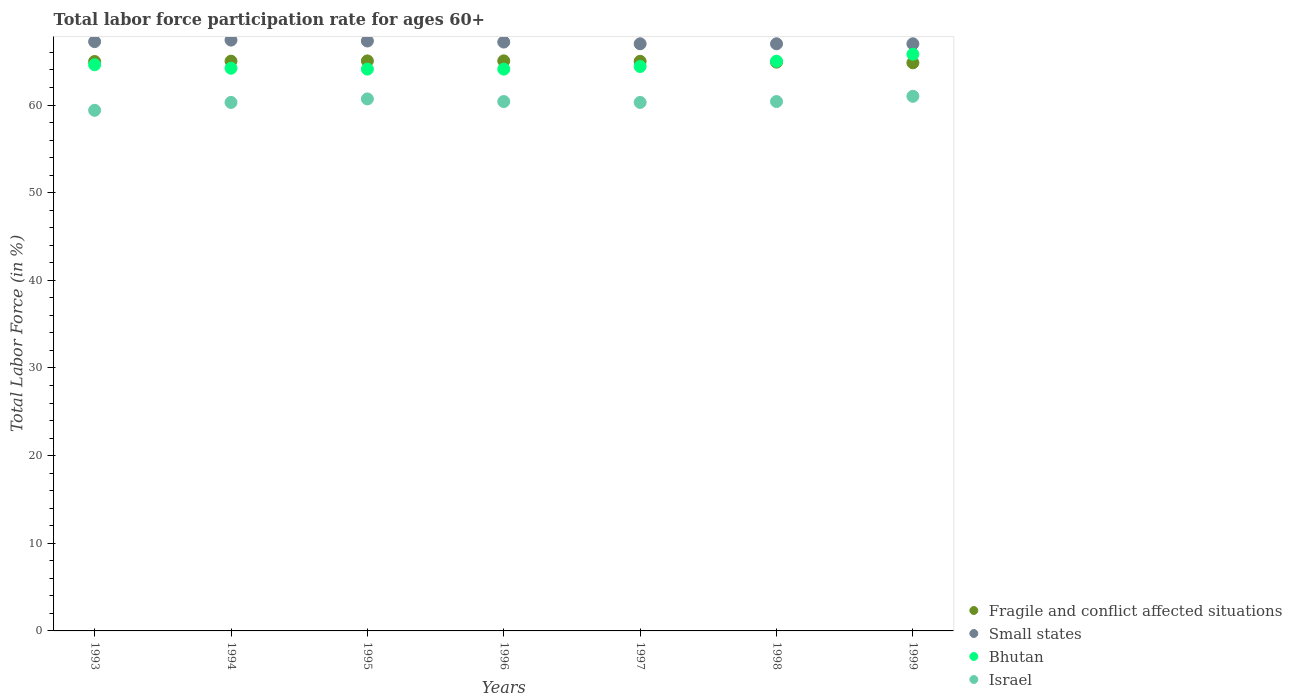Is the number of dotlines equal to the number of legend labels?
Offer a terse response. Yes. What is the labor force participation rate in Israel in 1993?
Provide a succinct answer. 59.4. Across all years, what is the maximum labor force participation rate in Fragile and conflict affected situations?
Your answer should be compact. 65.04. Across all years, what is the minimum labor force participation rate in Fragile and conflict affected situations?
Give a very brief answer. 64.82. In which year was the labor force participation rate in Small states minimum?
Give a very brief answer. 1999. What is the total labor force participation rate in Bhutan in the graph?
Provide a short and direct response. 452.2. What is the difference between the labor force participation rate in Bhutan in 1996 and that in 1998?
Make the answer very short. -0.9. What is the difference between the labor force participation rate in Small states in 1993 and the labor force participation rate in Israel in 1999?
Offer a very short reply. 6.24. What is the average labor force participation rate in Small states per year?
Keep it short and to the point. 67.16. In the year 1997, what is the difference between the labor force participation rate in Small states and labor force participation rate in Israel?
Keep it short and to the point. 6.69. In how many years, is the labor force participation rate in Bhutan greater than 10 %?
Your answer should be compact. 7. What is the ratio of the labor force participation rate in Small states in 1994 to that in 1995?
Your answer should be compact. 1. Is the difference between the labor force participation rate in Small states in 1993 and 1995 greater than the difference between the labor force participation rate in Israel in 1993 and 1995?
Keep it short and to the point. Yes. What is the difference between the highest and the second highest labor force participation rate in Bhutan?
Keep it short and to the point. 0.8. What is the difference between the highest and the lowest labor force participation rate in Israel?
Give a very brief answer. 1.6. Is the sum of the labor force participation rate in Israel in 1994 and 1997 greater than the maximum labor force participation rate in Fragile and conflict affected situations across all years?
Your answer should be very brief. Yes. Is it the case that in every year, the sum of the labor force participation rate in Fragile and conflict affected situations and labor force participation rate in Israel  is greater than the labor force participation rate in Bhutan?
Ensure brevity in your answer.  Yes. Does the labor force participation rate in Israel monotonically increase over the years?
Keep it short and to the point. No. Is the labor force participation rate in Bhutan strictly greater than the labor force participation rate in Small states over the years?
Provide a succinct answer. No. How many dotlines are there?
Your answer should be very brief. 4. How many years are there in the graph?
Ensure brevity in your answer.  7. Are the values on the major ticks of Y-axis written in scientific E-notation?
Make the answer very short. No. Does the graph contain grids?
Make the answer very short. No. How are the legend labels stacked?
Your answer should be very brief. Vertical. What is the title of the graph?
Provide a short and direct response. Total labor force participation rate for ages 60+. Does "Switzerland" appear as one of the legend labels in the graph?
Keep it short and to the point. No. What is the label or title of the X-axis?
Your answer should be very brief. Years. What is the Total Labor Force (in %) of Fragile and conflict affected situations in 1993?
Offer a terse response. 64.97. What is the Total Labor Force (in %) of Small states in 1993?
Provide a short and direct response. 67.24. What is the Total Labor Force (in %) of Bhutan in 1993?
Give a very brief answer. 64.6. What is the Total Labor Force (in %) of Israel in 1993?
Give a very brief answer. 59.4. What is the Total Labor Force (in %) of Fragile and conflict affected situations in 1994?
Your response must be concise. 65.01. What is the Total Labor Force (in %) of Small states in 1994?
Your answer should be very brief. 67.41. What is the Total Labor Force (in %) of Bhutan in 1994?
Offer a very short reply. 64.2. What is the Total Labor Force (in %) of Israel in 1994?
Keep it short and to the point. 60.3. What is the Total Labor Force (in %) of Fragile and conflict affected situations in 1995?
Provide a succinct answer. 65.04. What is the Total Labor Force (in %) of Small states in 1995?
Keep it short and to the point. 67.31. What is the Total Labor Force (in %) of Bhutan in 1995?
Give a very brief answer. 64.1. What is the Total Labor Force (in %) of Israel in 1995?
Provide a short and direct response. 60.7. What is the Total Labor Force (in %) in Fragile and conflict affected situations in 1996?
Give a very brief answer. 65.04. What is the Total Labor Force (in %) of Small states in 1996?
Your response must be concise. 67.19. What is the Total Labor Force (in %) in Bhutan in 1996?
Your response must be concise. 64.1. What is the Total Labor Force (in %) in Israel in 1996?
Keep it short and to the point. 60.4. What is the Total Labor Force (in %) in Fragile and conflict affected situations in 1997?
Your response must be concise. 64.99. What is the Total Labor Force (in %) of Small states in 1997?
Keep it short and to the point. 66.99. What is the Total Labor Force (in %) of Bhutan in 1997?
Ensure brevity in your answer.  64.4. What is the Total Labor Force (in %) in Israel in 1997?
Provide a short and direct response. 60.3. What is the Total Labor Force (in %) of Fragile and conflict affected situations in 1998?
Provide a succinct answer. 64.9. What is the Total Labor Force (in %) of Small states in 1998?
Offer a terse response. 66.99. What is the Total Labor Force (in %) of Israel in 1998?
Provide a succinct answer. 60.4. What is the Total Labor Force (in %) of Fragile and conflict affected situations in 1999?
Offer a terse response. 64.82. What is the Total Labor Force (in %) of Small states in 1999?
Offer a very short reply. 66.99. What is the Total Labor Force (in %) of Bhutan in 1999?
Your answer should be compact. 65.8. Across all years, what is the maximum Total Labor Force (in %) of Fragile and conflict affected situations?
Your answer should be very brief. 65.04. Across all years, what is the maximum Total Labor Force (in %) in Small states?
Your answer should be very brief. 67.41. Across all years, what is the maximum Total Labor Force (in %) of Bhutan?
Your answer should be compact. 65.8. Across all years, what is the maximum Total Labor Force (in %) in Israel?
Offer a very short reply. 61. Across all years, what is the minimum Total Labor Force (in %) in Fragile and conflict affected situations?
Provide a short and direct response. 64.82. Across all years, what is the minimum Total Labor Force (in %) in Small states?
Give a very brief answer. 66.99. Across all years, what is the minimum Total Labor Force (in %) of Bhutan?
Keep it short and to the point. 64.1. Across all years, what is the minimum Total Labor Force (in %) of Israel?
Offer a terse response. 59.4. What is the total Total Labor Force (in %) of Fragile and conflict affected situations in the graph?
Provide a short and direct response. 454.77. What is the total Total Labor Force (in %) in Small states in the graph?
Your answer should be compact. 470.11. What is the total Total Labor Force (in %) of Bhutan in the graph?
Your response must be concise. 452.2. What is the total Total Labor Force (in %) of Israel in the graph?
Offer a terse response. 422.5. What is the difference between the Total Labor Force (in %) of Fragile and conflict affected situations in 1993 and that in 1994?
Your answer should be very brief. -0.04. What is the difference between the Total Labor Force (in %) in Small states in 1993 and that in 1994?
Offer a very short reply. -0.18. What is the difference between the Total Labor Force (in %) in Fragile and conflict affected situations in 1993 and that in 1995?
Offer a terse response. -0.07. What is the difference between the Total Labor Force (in %) in Small states in 1993 and that in 1995?
Give a very brief answer. -0.07. What is the difference between the Total Labor Force (in %) of Fragile and conflict affected situations in 1993 and that in 1996?
Make the answer very short. -0.07. What is the difference between the Total Labor Force (in %) of Small states in 1993 and that in 1996?
Offer a terse response. 0.05. What is the difference between the Total Labor Force (in %) of Israel in 1993 and that in 1996?
Your response must be concise. -1. What is the difference between the Total Labor Force (in %) of Fragile and conflict affected situations in 1993 and that in 1997?
Your answer should be very brief. -0.02. What is the difference between the Total Labor Force (in %) in Small states in 1993 and that in 1997?
Your answer should be very brief. 0.25. What is the difference between the Total Labor Force (in %) of Fragile and conflict affected situations in 1993 and that in 1998?
Offer a very short reply. 0.07. What is the difference between the Total Labor Force (in %) of Small states in 1993 and that in 1998?
Make the answer very short. 0.25. What is the difference between the Total Labor Force (in %) of Bhutan in 1993 and that in 1998?
Keep it short and to the point. -0.4. What is the difference between the Total Labor Force (in %) in Israel in 1993 and that in 1998?
Provide a succinct answer. -1. What is the difference between the Total Labor Force (in %) of Fragile and conflict affected situations in 1993 and that in 1999?
Offer a terse response. 0.15. What is the difference between the Total Labor Force (in %) in Small states in 1993 and that in 1999?
Keep it short and to the point. 0.25. What is the difference between the Total Labor Force (in %) of Fragile and conflict affected situations in 1994 and that in 1995?
Provide a short and direct response. -0.03. What is the difference between the Total Labor Force (in %) in Small states in 1994 and that in 1995?
Offer a terse response. 0.1. What is the difference between the Total Labor Force (in %) of Israel in 1994 and that in 1995?
Make the answer very short. -0.4. What is the difference between the Total Labor Force (in %) in Fragile and conflict affected situations in 1994 and that in 1996?
Offer a terse response. -0.04. What is the difference between the Total Labor Force (in %) in Small states in 1994 and that in 1996?
Your answer should be very brief. 0.23. What is the difference between the Total Labor Force (in %) of Fragile and conflict affected situations in 1994 and that in 1997?
Keep it short and to the point. 0.02. What is the difference between the Total Labor Force (in %) of Small states in 1994 and that in 1997?
Provide a succinct answer. 0.42. What is the difference between the Total Labor Force (in %) in Israel in 1994 and that in 1997?
Your response must be concise. 0. What is the difference between the Total Labor Force (in %) of Fragile and conflict affected situations in 1994 and that in 1998?
Ensure brevity in your answer.  0.11. What is the difference between the Total Labor Force (in %) in Small states in 1994 and that in 1998?
Provide a succinct answer. 0.42. What is the difference between the Total Labor Force (in %) of Israel in 1994 and that in 1998?
Ensure brevity in your answer.  -0.1. What is the difference between the Total Labor Force (in %) of Fragile and conflict affected situations in 1994 and that in 1999?
Provide a short and direct response. 0.19. What is the difference between the Total Labor Force (in %) in Small states in 1994 and that in 1999?
Provide a succinct answer. 0.42. What is the difference between the Total Labor Force (in %) of Bhutan in 1994 and that in 1999?
Your answer should be very brief. -1.6. What is the difference between the Total Labor Force (in %) in Fragile and conflict affected situations in 1995 and that in 1996?
Offer a very short reply. -0. What is the difference between the Total Labor Force (in %) in Small states in 1995 and that in 1996?
Your answer should be very brief. 0.12. What is the difference between the Total Labor Force (in %) of Fragile and conflict affected situations in 1995 and that in 1997?
Your response must be concise. 0.05. What is the difference between the Total Labor Force (in %) of Small states in 1995 and that in 1997?
Your answer should be very brief. 0.32. What is the difference between the Total Labor Force (in %) of Fragile and conflict affected situations in 1995 and that in 1998?
Ensure brevity in your answer.  0.14. What is the difference between the Total Labor Force (in %) in Small states in 1995 and that in 1998?
Ensure brevity in your answer.  0.32. What is the difference between the Total Labor Force (in %) of Bhutan in 1995 and that in 1998?
Offer a very short reply. -0.9. What is the difference between the Total Labor Force (in %) of Israel in 1995 and that in 1998?
Your answer should be very brief. 0.3. What is the difference between the Total Labor Force (in %) of Fragile and conflict affected situations in 1995 and that in 1999?
Your response must be concise. 0.22. What is the difference between the Total Labor Force (in %) in Small states in 1995 and that in 1999?
Give a very brief answer. 0.32. What is the difference between the Total Labor Force (in %) in Israel in 1995 and that in 1999?
Provide a short and direct response. -0.3. What is the difference between the Total Labor Force (in %) in Fragile and conflict affected situations in 1996 and that in 1997?
Provide a succinct answer. 0.05. What is the difference between the Total Labor Force (in %) of Small states in 1996 and that in 1997?
Ensure brevity in your answer.  0.2. What is the difference between the Total Labor Force (in %) in Bhutan in 1996 and that in 1997?
Provide a succinct answer. -0.3. What is the difference between the Total Labor Force (in %) in Fragile and conflict affected situations in 1996 and that in 1998?
Provide a short and direct response. 0.14. What is the difference between the Total Labor Force (in %) in Small states in 1996 and that in 1998?
Provide a succinct answer. 0.2. What is the difference between the Total Labor Force (in %) in Bhutan in 1996 and that in 1998?
Give a very brief answer. -0.9. What is the difference between the Total Labor Force (in %) in Fragile and conflict affected situations in 1996 and that in 1999?
Make the answer very short. 0.22. What is the difference between the Total Labor Force (in %) in Small states in 1996 and that in 1999?
Make the answer very short. 0.2. What is the difference between the Total Labor Force (in %) of Bhutan in 1996 and that in 1999?
Make the answer very short. -1.7. What is the difference between the Total Labor Force (in %) in Israel in 1996 and that in 1999?
Give a very brief answer. -0.6. What is the difference between the Total Labor Force (in %) of Fragile and conflict affected situations in 1997 and that in 1998?
Give a very brief answer. 0.09. What is the difference between the Total Labor Force (in %) of Small states in 1997 and that in 1998?
Offer a terse response. 0. What is the difference between the Total Labor Force (in %) in Bhutan in 1997 and that in 1998?
Provide a short and direct response. -0.6. What is the difference between the Total Labor Force (in %) of Israel in 1997 and that in 1998?
Keep it short and to the point. -0.1. What is the difference between the Total Labor Force (in %) in Fragile and conflict affected situations in 1997 and that in 1999?
Keep it short and to the point. 0.17. What is the difference between the Total Labor Force (in %) in Small states in 1997 and that in 1999?
Your response must be concise. 0. What is the difference between the Total Labor Force (in %) of Fragile and conflict affected situations in 1998 and that in 1999?
Make the answer very short. 0.08. What is the difference between the Total Labor Force (in %) of Small states in 1998 and that in 1999?
Offer a terse response. 0. What is the difference between the Total Labor Force (in %) of Fragile and conflict affected situations in 1993 and the Total Labor Force (in %) of Small states in 1994?
Give a very brief answer. -2.44. What is the difference between the Total Labor Force (in %) in Fragile and conflict affected situations in 1993 and the Total Labor Force (in %) in Bhutan in 1994?
Keep it short and to the point. 0.77. What is the difference between the Total Labor Force (in %) in Fragile and conflict affected situations in 1993 and the Total Labor Force (in %) in Israel in 1994?
Give a very brief answer. 4.67. What is the difference between the Total Labor Force (in %) of Small states in 1993 and the Total Labor Force (in %) of Bhutan in 1994?
Provide a succinct answer. 3.04. What is the difference between the Total Labor Force (in %) of Small states in 1993 and the Total Labor Force (in %) of Israel in 1994?
Ensure brevity in your answer.  6.94. What is the difference between the Total Labor Force (in %) in Bhutan in 1993 and the Total Labor Force (in %) in Israel in 1994?
Your response must be concise. 4.3. What is the difference between the Total Labor Force (in %) in Fragile and conflict affected situations in 1993 and the Total Labor Force (in %) in Small states in 1995?
Keep it short and to the point. -2.34. What is the difference between the Total Labor Force (in %) of Fragile and conflict affected situations in 1993 and the Total Labor Force (in %) of Bhutan in 1995?
Make the answer very short. 0.87. What is the difference between the Total Labor Force (in %) of Fragile and conflict affected situations in 1993 and the Total Labor Force (in %) of Israel in 1995?
Give a very brief answer. 4.27. What is the difference between the Total Labor Force (in %) of Small states in 1993 and the Total Labor Force (in %) of Bhutan in 1995?
Give a very brief answer. 3.14. What is the difference between the Total Labor Force (in %) of Small states in 1993 and the Total Labor Force (in %) of Israel in 1995?
Ensure brevity in your answer.  6.54. What is the difference between the Total Labor Force (in %) in Bhutan in 1993 and the Total Labor Force (in %) in Israel in 1995?
Offer a very short reply. 3.9. What is the difference between the Total Labor Force (in %) of Fragile and conflict affected situations in 1993 and the Total Labor Force (in %) of Small states in 1996?
Make the answer very short. -2.22. What is the difference between the Total Labor Force (in %) in Fragile and conflict affected situations in 1993 and the Total Labor Force (in %) in Bhutan in 1996?
Ensure brevity in your answer.  0.87. What is the difference between the Total Labor Force (in %) of Fragile and conflict affected situations in 1993 and the Total Labor Force (in %) of Israel in 1996?
Provide a short and direct response. 4.57. What is the difference between the Total Labor Force (in %) of Small states in 1993 and the Total Labor Force (in %) of Bhutan in 1996?
Keep it short and to the point. 3.14. What is the difference between the Total Labor Force (in %) in Small states in 1993 and the Total Labor Force (in %) in Israel in 1996?
Keep it short and to the point. 6.84. What is the difference between the Total Labor Force (in %) of Bhutan in 1993 and the Total Labor Force (in %) of Israel in 1996?
Make the answer very short. 4.2. What is the difference between the Total Labor Force (in %) of Fragile and conflict affected situations in 1993 and the Total Labor Force (in %) of Small states in 1997?
Provide a short and direct response. -2.02. What is the difference between the Total Labor Force (in %) in Fragile and conflict affected situations in 1993 and the Total Labor Force (in %) in Bhutan in 1997?
Provide a succinct answer. 0.57. What is the difference between the Total Labor Force (in %) of Fragile and conflict affected situations in 1993 and the Total Labor Force (in %) of Israel in 1997?
Provide a succinct answer. 4.67. What is the difference between the Total Labor Force (in %) of Small states in 1993 and the Total Labor Force (in %) of Bhutan in 1997?
Make the answer very short. 2.84. What is the difference between the Total Labor Force (in %) in Small states in 1993 and the Total Labor Force (in %) in Israel in 1997?
Your answer should be very brief. 6.94. What is the difference between the Total Labor Force (in %) in Bhutan in 1993 and the Total Labor Force (in %) in Israel in 1997?
Keep it short and to the point. 4.3. What is the difference between the Total Labor Force (in %) in Fragile and conflict affected situations in 1993 and the Total Labor Force (in %) in Small states in 1998?
Give a very brief answer. -2.02. What is the difference between the Total Labor Force (in %) of Fragile and conflict affected situations in 1993 and the Total Labor Force (in %) of Bhutan in 1998?
Give a very brief answer. -0.03. What is the difference between the Total Labor Force (in %) of Fragile and conflict affected situations in 1993 and the Total Labor Force (in %) of Israel in 1998?
Your response must be concise. 4.57. What is the difference between the Total Labor Force (in %) of Small states in 1993 and the Total Labor Force (in %) of Bhutan in 1998?
Your response must be concise. 2.24. What is the difference between the Total Labor Force (in %) in Small states in 1993 and the Total Labor Force (in %) in Israel in 1998?
Ensure brevity in your answer.  6.84. What is the difference between the Total Labor Force (in %) in Fragile and conflict affected situations in 1993 and the Total Labor Force (in %) in Small states in 1999?
Your answer should be very brief. -2.02. What is the difference between the Total Labor Force (in %) in Fragile and conflict affected situations in 1993 and the Total Labor Force (in %) in Bhutan in 1999?
Provide a succinct answer. -0.83. What is the difference between the Total Labor Force (in %) of Fragile and conflict affected situations in 1993 and the Total Labor Force (in %) of Israel in 1999?
Your response must be concise. 3.97. What is the difference between the Total Labor Force (in %) of Small states in 1993 and the Total Labor Force (in %) of Bhutan in 1999?
Provide a short and direct response. 1.44. What is the difference between the Total Labor Force (in %) of Small states in 1993 and the Total Labor Force (in %) of Israel in 1999?
Your answer should be compact. 6.24. What is the difference between the Total Labor Force (in %) in Bhutan in 1993 and the Total Labor Force (in %) in Israel in 1999?
Provide a succinct answer. 3.6. What is the difference between the Total Labor Force (in %) in Fragile and conflict affected situations in 1994 and the Total Labor Force (in %) in Small states in 1995?
Provide a succinct answer. -2.3. What is the difference between the Total Labor Force (in %) of Fragile and conflict affected situations in 1994 and the Total Labor Force (in %) of Bhutan in 1995?
Ensure brevity in your answer.  0.91. What is the difference between the Total Labor Force (in %) in Fragile and conflict affected situations in 1994 and the Total Labor Force (in %) in Israel in 1995?
Your response must be concise. 4.31. What is the difference between the Total Labor Force (in %) of Small states in 1994 and the Total Labor Force (in %) of Bhutan in 1995?
Your response must be concise. 3.31. What is the difference between the Total Labor Force (in %) in Small states in 1994 and the Total Labor Force (in %) in Israel in 1995?
Provide a short and direct response. 6.71. What is the difference between the Total Labor Force (in %) of Bhutan in 1994 and the Total Labor Force (in %) of Israel in 1995?
Keep it short and to the point. 3.5. What is the difference between the Total Labor Force (in %) in Fragile and conflict affected situations in 1994 and the Total Labor Force (in %) in Small states in 1996?
Keep it short and to the point. -2.18. What is the difference between the Total Labor Force (in %) in Fragile and conflict affected situations in 1994 and the Total Labor Force (in %) in Bhutan in 1996?
Keep it short and to the point. 0.91. What is the difference between the Total Labor Force (in %) in Fragile and conflict affected situations in 1994 and the Total Labor Force (in %) in Israel in 1996?
Your answer should be compact. 4.61. What is the difference between the Total Labor Force (in %) in Small states in 1994 and the Total Labor Force (in %) in Bhutan in 1996?
Offer a very short reply. 3.31. What is the difference between the Total Labor Force (in %) in Small states in 1994 and the Total Labor Force (in %) in Israel in 1996?
Offer a terse response. 7.01. What is the difference between the Total Labor Force (in %) of Fragile and conflict affected situations in 1994 and the Total Labor Force (in %) of Small states in 1997?
Your response must be concise. -1.98. What is the difference between the Total Labor Force (in %) of Fragile and conflict affected situations in 1994 and the Total Labor Force (in %) of Bhutan in 1997?
Keep it short and to the point. 0.61. What is the difference between the Total Labor Force (in %) of Fragile and conflict affected situations in 1994 and the Total Labor Force (in %) of Israel in 1997?
Provide a short and direct response. 4.71. What is the difference between the Total Labor Force (in %) of Small states in 1994 and the Total Labor Force (in %) of Bhutan in 1997?
Keep it short and to the point. 3.01. What is the difference between the Total Labor Force (in %) of Small states in 1994 and the Total Labor Force (in %) of Israel in 1997?
Your response must be concise. 7.11. What is the difference between the Total Labor Force (in %) in Fragile and conflict affected situations in 1994 and the Total Labor Force (in %) in Small states in 1998?
Provide a succinct answer. -1.98. What is the difference between the Total Labor Force (in %) in Fragile and conflict affected situations in 1994 and the Total Labor Force (in %) in Bhutan in 1998?
Your answer should be very brief. 0.01. What is the difference between the Total Labor Force (in %) of Fragile and conflict affected situations in 1994 and the Total Labor Force (in %) of Israel in 1998?
Make the answer very short. 4.61. What is the difference between the Total Labor Force (in %) in Small states in 1994 and the Total Labor Force (in %) in Bhutan in 1998?
Your answer should be very brief. 2.41. What is the difference between the Total Labor Force (in %) of Small states in 1994 and the Total Labor Force (in %) of Israel in 1998?
Your answer should be very brief. 7.01. What is the difference between the Total Labor Force (in %) of Bhutan in 1994 and the Total Labor Force (in %) of Israel in 1998?
Offer a very short reply. 3.8. What is the difference between the Total Labor Force (in %) in Fragile and conflict affected situations in 1994 and the Total Labor Force (in %) in Small states in 1999?
Keep it short and to the point. -1.98. What is the difference between the Total Labor Force (in %) of Fragile and conflict affected situations in 1994 and the Total Labor Force (in %) of Bhutan in 1999?
Offer a terse response. -0.79. What is the difference between the Total Labor Force (in %) in Fragile and conflict affected situations in 1994 and the Total Labor Force (in %) in Israel in 1999?
Keep it short and to the point. 4.01. What is the difference between the Total Labor Force (in %) of Small states in 1994 and the Total Labor Force (in %) of Bhutan in 1999?
Your answer should be very brief. 1.61. What is the difference between the Total Labor Force (in %) in Small states in 1994 and the Total Labor Force (in %) in Israel in 1999?
Offer a very short reply. 6.41. What is the difference between the Total Labor Force (in %) in Fragile and conflict affected situations in 1995 and the Total Labor Force (in %) in Small states in 1996?
Provide a succinct answer. -2.15. What is the difference between the Total Labor Force (in %) in Fragile and conflict affected situations in 1995 and the Total Labor Force (in %) in Bhutan in 1996?
Give a very brief answer. 0.94. What is the difference between the Total Labor Force (in %) in Fragile and conflict affected situations in 1995 and the Total Labor Force (in %) in Israel in 1996?
Ensure brevity in your answer.  4.64. What is the difference between the Total Labor Force (in %) in Small states in 1995 and the Total Labor Force (in %) in Bhutan in 1996?
Keep it short and to the point. 3.21. What is the difference between the Total Labor Force (in %) in Small states in 1995 and the Total Labor Force (in %) in Israel in 1996?
Offer a very short reply. 6.91. What is the difference between the Total Labor Force (in %) in Fragile and conflict affected situations in 1995 and the Total Labor Force (in %) in Small states in 1997?
Give a very brief answer. -1.95. What is the difference between the Total Labor Force (in %) of Fragile and conflict affected situations in 1995 and the Total Labor Force (in %) of Bhutan in 1997?
Make the answer very short. 0.64. What is the difference between the Total Labor Force (in %) of Fragile and conflict affected situations in 1995 and the Total Labor Force (in %) of Israel in 1997?
Your response must be concise. 4.74. What is the difference between the Total Labor Force (in %) of Small states in 1995 and the Total Labor Force (in %) of Bhutan in 1997?
Make the answer very short. 2.91. What is the difference between the Total Labor Force (in %) in Small states in 1995 and the Total Labor Force (in %) in Israel in 1997?
Ensure brevity in your answer.  7.01. What is the difference between the Total Labor Force (in %) of Fragile and conflict affected situations in 1995 and the Total Labor Force (in %) of Small states in 1998?
Provide a short and direct response. -1.95. What is the difference between the Total Labor Force (in %) of Fragile and conflict affected situations in 1995 and the Total Labor Force (in %) of Bhutan in 1998?
Your answer should be very brief. 0.04. What is the difference between the Total Labor Force (in %) of Fragile and conflict affected situations in 1995 and the Total Labor Force (in %) of Israel in 1998?
Provide a short and direct response. 4.64. What is the difference between the Total Labor Force (in %) of Small states in 1995 and the Total Labor Force (in %) of Bhutan in 1998?
Provide a short and direct response. 2.31. What is the difference between the Total Labor Force (in %) in Small states in 1995 and the Total Labor Force (in %) in Israel in 1998?
Offer a very short reply. 6.91. What is the difference between the Total Labor Force (in %) in Fragile and conflict affected situations in 1995 and the Total Labor Force (in %) in Small states in 1999?
Offer a terse response. -1.95. What is the difference between the Total Labor Force (in %) of Fragile and conflict affected situations in 1995 and the Total Labor Force (in %) of Bhutan in 1999?
Ensure brevity in your answer.  -0.76. What is the difference between the Total Labor Force (in %) in Fragile and conflict affected situations in 1995 and the Total Labor Force (in %) in Israel in 1999?
Give a very brief answer. 4.04. What is the difference between the Total Labor Force (in %) in Small states in 1995 and the Total Labor Force (in %) in Bhutan in 1999?
Your answer should be compact. 1.51. What is the difference between the Total Labor Force (in %) of Small states in 1995 and the Total Labor Force (in %) of Israel in 1999?
Provide a short and direct response. 6.31. What is the difference between the Total Labor Force (in %) in Fragile and conflict affected situations in 1996 and the Total Labor Force (in %) in Small states in 1997?
Give a very brief answer. -1.95. What is the difference between the Total Labor Force (in %) in Fragile and conflict affected situations in 1996 and the Total Labor Force (in %) in Bhutan in 1997?
Your response must be concise. 0.64. What is the difference between the Total Labor Force (in %) of Fragile and conflict affected situations in 1996 and the Total Labor Force (in %) of Israel in 1997?
Provide a succinct answer. 4.74. What is the difference between the Total Labor Force (in %) of Small states in 1996 and the Total Labor Force (in %) of Bhutan in 1997?
Keep it short and to the point. 2.79. What is the difference between the Total Labor Force (in %) of Small states in 1996 and the Total Labor Force (in %) of Israel in 1997?
Your answer should be very brief. 6.89. What is the difference between the Total Labor Force (in %) in Fragile and conflict affected situations in 1996 and the Total Labor Force (in %) in Small states in 1998?
Your response must be concise. -1.95. What is the difference between the Total Labor Force (in %) of Fragile and conflict affected situations in 1996 and the Total Labor Force (in %) of Bhutan in 1998?
Provide a short and direct response. 0.04. What is the difference between the Total Labor Force (in %) in Fragile and conflict affected situations in 1996 and the Total Labor Force (in %) in Israel in 1998?
Offer a very short reply. 4.64. What is the difference between the Total Labor Force (in %) in Small states in 1996 and the Total Labor Force (in %) in Bhutan in 1998?
Offer a terse response. 2.19. What is the difference between the Total Labor Force (in %) of Small states in 1996 and the Total Labor Force (in %) of Israel in 1998?
Your response must be concise. 6.79. What is the difference between the Total Labor Force (in %) of Bhutan in 1996 and the Total Labor Force (in %) of Israel in 1998?
Keep it short and to the point. 3.7. What is the difference between the Total Labor Force (in %) in Fragile and conflict affected situations in 1996 and the Total Labor Force (in %) in Small states in 1999?
Your response must be concise. -1.95. What is the difference between the Total Labor Force (in %) in Fragile and conflict affected situations in 1996 and the Total Labor Force (in %) in Bhutan in 1999?
Provide a succinct answer. -0.76. What is the difference between the Total Labor Force (in %) in Fragile and conflict affected situations in 1996 and the Total Labor Force (in %) in Israel in 1999?
Provide a short and direct response. 4.04. What is the difference between the Total Labor Force (in %) in Small states in 1996 and the Total Labor Force (in %) in Bhutan in 1999?
Offer a very short reply. 1.39. What is the difference between the Total Labor Force (in %) in Small states in 1996 and the Total Labor Force (in %) in Israel in 1999?
Provide a succinct answer. 6.19. What is the difference between the Total Labor Force (in %) of Fragile and conflict affected situations in 1997 and the Total Labor Force (in %) of Small states in 1998?
Your answer should be compact. -2. What is the difference between the Total Labor Force (in %) in Fragile and conflict affected situations in 1997 and the Total Labor Force (in %) in Bhutan in 1998?
Ensure brevity in your answer.  -0.01. What is the difference between the Total Labor Force (in %) of Fragile and conflict affected situations in 1997 and the Total Labor Force (in %) of Israel in 1998?
Provide a short and direct response. 4.59. What is the difference between the Total Labor Force (in %) in Small states in 1997 and the Total Labor Force (in %) in Bhutan in 1998?
Give a very brief answer. 1.99. What is the difference between the Total Labor Force (in %) of Small states in 1997 and the Total Labor Force (in %) of Israel in 1998?
Your response must be concise. 6.59. What is the difference between the Total Labor Force (in %) of Fragile and conflict affected situations in 1997 and the Total Labor Force (in %) of Small states in 1999?
Provide a short and direct response. -2. What is the difference between the Total Labor Force (in %) of Fragile and conflict affected situations in 1997 and the Total Labor Force (in %) of Bhutan in 1999?
Offer a terse response. -0.81. What is the difference between the Total Labor Force (in %) in Fragile and conflict affected situations in 1997 and the Total Labor Force (in %) in Israel in 1999?
Offer a very short reply. 3.99. What is the difference between the Total Labor Force (in %) in Small states in 1997 and the Total Labor Force (in %) in Bhutan in 1999?
Offer a terse response. 1.19. What is the difference between the Total Labor Force (in %) of Small states in 1997 and the Total Labor Force (in %) of Israel in 1999?
Offer a very short reply. 5.99. What is the difference between the Total Labor Force (in %) in Bhutan in 1997 and the Total Labor Force (in %) in Israel in 1999?
Keep it short and to the point. 3.4. What is the difference between the Total Labor Force (in %) of Fragile and conflict affected situations in 1998 and the Total Labor Force (in %) of Small states in 1999?
Ensure brevity in your answer.  -2.09. What is the difference between the Total Labor Force (in %) of Fragile and conflict affected situations in 1998 and the Total Labor Force (in %) of Bhutan in 1999?
Give a very brief answer. -0.9. What is the difference between the Total Labor Force (in %) of Fragile and conflict affected situations in 1998 and the Total Labor Force (in %) of Israel in 1999?
Your answer should be compact. 3.9. What is the difference between the Total Labor Force (in %) in Small states in 1998 and the Total Labor Force (in %) in Bhutan in 1999?
Keep it short and to the point. 1.19. What is the difference between the Total Labor Force (in %) of Small states in 1998 and the Total Labor Force (in %) of Israel in 1999?
Make the answer very short. 5.99. What is the average Total Labor Force (in %) of Fragile and conflict affected situations per year?
Your answer should be very brief. 64.97. What is the average Total Labor Force (in %) in Small states per year?
Keep it short and to the point. 67.16. What is the average Total Labor Force (in %) in Bhutan per year?
Offer a very short reply. 64.6. What is the average Total Labor Force (in %) in Israel per year?
Give a very brief answer. 60.36. In the year 1993, what is the difference between the Total Labor Force (in %) in Fragile and conflict affected situations and Total Labor Force (in %) in Small states?
Ensure brevity in your answer.  -2.27. In the year 1993, what is the difference between the Total Labor Force (in %) of Fragile and conflict affected situations and Total Labor Force (in %) of Bhutan?
Offer a terse response. 0.37. In the year 1993, what is the difference between the Total Labor Force (in %) of Fragile and conflict affected situations and Total Labor Force (in %) of Israel?
Keep it short and to the point. 5.57. In the year 1993, what is the difference between the Total Labor Force (in %) of Small states and Total Labor Force (in %) of Bhutan?
Provide a short and direct response. 2.64. In the year 1993, what is the difference between the Total Labor Force (in %) in Small states and Total Labor Force (in %) in Israel?
Your response must be concise. 7.84. In the year 1993, what is the difference between the Total Labor Force (in %) of Bhutan and Total Labor Force (in %) of Israel?
Offer a terse response. 5.2. In the year 1994, what is the difference between the Total Labor Force (in %) in Fragile and conflict affected situations and Total Labor Force (in %) in Small states?
Ensure brevity in your answer.  -2.41. In the year 1994, what is the difference between the Total Labor Force (in %) in Fragile and conflict affected situations and Total Labor Force (in %) in Bhutan?
Make the answer very short. 0.81. In the year 1994, what is the difference between the Total Labor Force (in %) of Fragile and conflict affected situations and Total Labor Force (in %) of Israel?
Give a very brief answer. 4.71. In the year 1994, what is the difference between the Total Labor Force (in %) of Small states and Total Labor Force (in %) of Bhutan?
Keep it short and to the point. 3.21. In the year 1994, what is the difference between the Total Labor Force (in %) of Small states and Total Labor Force (in %) of Israel?
Your answer should be very brief. 7.11. In the year 1995, what is the difference between the Total Labor Force (in %) of Fragile and conflict affected situations and Total Labor Force (in %) of Small states?
Keep it short and to the point. -2.27. In the year 1995, what is the difference between the Total Labor Force (in %) in Fragile and conflict affected situations and Total Labor Force (in %) in Bhutan?
Provide a succinct answer. 0.94. In the year 1995, what is the difference between the Total Labor Force (in %) of Fragile and conflict affected situations and Total Labor Force (in %) of Israel?
Provide a succinct answer. 4.34. In the year 1995, what is the difference between the Total Labor Force (in %) in Small states and Total Labor Force (in %) in Bhutan?
Your response must be concise. 3.21. In the year 1995, what is the difference between the Total Labor Force (in %) of Small states and Total Labor Force (in %) of Israel?
Give a very brief answer. 6.61. In the year 1995, what is the difference between the Total Labor Force (in %) of Bhutan and Total Labor Force (in %) of Israel?
Your answer should be compact. 3.4. In the year 1996, what is the difference between the Total Labor Force (in %) of Fragile and conflict affected situations and Total Labor Force (in %) of Small states?
Provide a short and direct response. -2.14. In the year 1996, what is the difference between the Total Labor Force (in %) of Fragile and conflict affected situations and Total Labor Force (in %) of Bhutan?
Provide a succinct answer. 0.94. In the year 1996, what is the difference between the Total Labor Force (in %) of Fragile and conflict affected situations and Total Labor Force (in %) of Israel?
Provide a succinct answer. 4.64. In the year 1996, what is the difference between the Total Labor Force (in %) of Small states and Total Labor Force (in %) of Bhutan?
Offer a terse response. 3.09. In the year 1996, what is the difference between the Total Labor Force (in %) in Small states and Total Labor Force (in %) in Israel?
Offer a very short reply. 6.79. In the year 1997, what is the difference between the Total Labor Force (in %) of Fragile and conflict affected situations and Total Labor Force (in %) of Small states?
Provide a short and direct response. -2. In the year 1997, what is the difference between the Total Labor Force (in %) of Fragile and conflict affected situations and Total Labor Force (in %) of Bhutan?
Ensure brevity in your answer.  0.59. In the year 1997, what is the difference between the Total Labor Force (in %) of Fragile and conflict affected situations and Total Labor Force (in %) of Israel?
Offer a very short reply. 4.69. In the year 1997, what is the difference between the Total Labor Force (in %) in Small states and Total Labor Force (in %) in Bhutan?
Your response must be concise. 2.59. In the year 1997, what is the difference between the Total Labor Force (in %) of Small states and Total Labor Force (in %) of Israel?
Your answer should be compact. 6.69. In the year 1998, what is the difference between the Total Labor Force (in %) in Fragile and conflict affected situations and Total Labor Force (in %) in Small states?
Your answer should be very brief. -2.09. In the year 1998, what is the difference between the Total Labor Force (in %) of Fragile and conflict affected situations and Total Labor Force (in %) of Bhutan?
Give a very brief answer. -0.1. In the year 1998, what is the difference between the Total Labor Force (in %) of Fragile and conflict affected situations and Total Labor Force (in %) of Israel?
Your answer should be compact. 4.5. In the year 1998, what is the difference between the Total Labor Force (in %) of Small states and Total Labor Force (in %) of Bhutan?
Offer a very short reply. 1.99. In the year 1998, what is the difference between the Total Labor Force (in %) in Small states and Total Labor Force (in %) in Israel?
Your response must be concise. 6.59. In the year 1999, what is the difference between the Total Labor Force (in %) in Fragile and conflict affected situations and Total Labor Force (in %) in Small states?
Your response must be concise. -2.17. In the year 1999, what is the difference between the Total Labor Force (in %) of Fragile and conflict affected situations and Total Labor Force (in %) of Bhutan?
Offer a terse response. -0.98. In the year 1999, what is the difference between the Total Labor Force (in %) of Fragile and conflict affected situations and Total Labor Force (in %) of Israel?
Offer a terse response. 3.82. In the year 1999, what is the difference between the Total Labor Force (in %) of Small states and Total Labor Force (in %) of Bhutan?
Keep it short and to the point. 1.19. In the year 1999, what is the difference between the Total Labor Force (in %) in Small states and Total Labor Force (in %) in Israel?
Offer a terse response. 5.99. What is the ratio of the Total Labor Force (in %) of Fragile and conflict affected situations in 1993 to that in 1994?
Keep it short and to the point. 1. What is the ratio of the Total Labor Force (in %) of Bhutan in 1993 to that in 1994?
Your answer should be compact. 1.01. What is the ratio of the Total Labor Force (in %) in Israel in 1993 to that in 1994?
Your response must be concise. 0.99. What is the ratio of the Total Labor Force (in %) in Small states in 1993 to that in 1995?
Your response must be concise. 1. What is the ratio of the Total Labor Force (in %) of Bhutan in 1993 to that in 1995?
Keep it short and to the point. 1.01. What is the ratio of the Total Labor Force (in %) of Israel in 1993 to that in 1995?
Your answer should be compact. 0.98. What is the ratio of the Total Labor Force (in %) in Israel in 1993 to that in 1996?
Provide a short and direct response. 0.98. What is the ratio of the Total Labor Force (in %) in Small states in 1993 to that in 1997?
Your answer should be compact. 1. What is the ratio of the Total Labor Force (in %) of Bhutan in 1993 to that in 1997?
Your response must be concise. 1. What is the ratio of the Total Labor Force (in %) in Israel in 1993 to that in 1997?
Ensure brevity in your answer.  0.99. What is the ratio of the Total Labor Force (in %) of Fragile and conflict affected situations in 1993 to that in 1998?
Your response must be concise. 1. What is the ratio of the Total Labor Force (in %) in Bhutan in 1993 to that in 1998?
Offer a terse response. 0.99. What is the ratio of the Total Labor Force (in %) in Israel in 1993 to that in 1998?
Keep it short and to the point. 0.98. What is the ratio of the Total Labor Force (in %) of Small states in 1993 to that in 1999?
Offer a very short reply. 1. What is the ratio of the Total Labor Force (in %) in Bhutan in 1993 to that in 1999?
Make the answer very short. 0.98. What is the ratio of the Total Labor Force (in %) of Israel in 1993 to that in 1999?
Your response must be concise. 0.97. What is the ratio of the Total Labor Force (in %) of Bhutan in 1994 to that in 1995?
Give a very brief answer. 1. What is the ratio of the Total Labor Force (in %) of Fragile and conflict affected situations in 1994 to that in 1996?
Your answer should be compact. 1. What is the ratio of the Total Labor Force (in %) in Small states in 1994 to that in 1996?
Provide a short and direct response. 1. What is the ratio of the Total Labor Force (in %) of Israel in 1994 to that in 1996?
Your answer should be compact. 1. What is the ratio of the Total Labor Force (in %) of Bhutan in 1994 to that in 1997?
Keep it short and to the point. 1. What is the ratio of the Total Labor Force (in %) in Fragile and conflict affected situations in 1994 to that in 1998?
Provide a succinct answer. 1. What is the ratio of the Total Labor Force (in %) in Small states in 1994 to that in 1998?
Your answer should be very brief. 1.01. What is the ratio of the Total Labor Force (in %) of Israel in 1994 to that in 1998?
Keep it short and to the point. 1. What is the ratio of the Total Labor Force (in %) in Bhutan in 1994 to that in 1999?
Ensure brevity in your answer.  0.98. What is the ratio of the Total Labor Force (in %) in Small states in 1995 to that in 1996?
Provide a short and direct response. 1. What is the ratio of the Total Labor Force (in %) in Bhutan in 1995 to that in 1996?
Your answer should be compact. 1. What is the ratio of the Total Labor Force (in %) of Israel in 1995 to that in 1996?
Your answer should be very brief. 1. What is the ratio of the Total Labor Force (in %) in Fragile and conflict affected situations in 1995 to that in 1997?
Your answer should be very brief. 1. What is the ratio of the Total Labor Force (in %) of Bhutan in 1995 to that in 1997?
Your answer should be compact. 1. What is the ratio of the Total Labor Force (in %) of Israel in 1995 to that in 1997?
Your response must be concise. 1.01. What is the ratio of the Total Labor Force (in %) in Bhutan in 1995 to that in 1998?
Offer a terse response. 0.99. What is the ratio of the Total Labor Force (in %) in Fragile and conflict affected situations in 1995 to that in 1999?
Give a very brief answer. 1. What is the ratio of the Total Labor Force (in %) of Small states in 1995 to that in 1999?
Provide a succinct answer. 1. What is the ratio of the Total Labor Force (in %) in Bhutan in 1995 to that in 1999?
Offer a terse response. 0.97. What is the ratio of the Total Labor Force (in %) in Fragile and conflict affected situations in 1996 to that in 1997?
Make the answer very short. 1. What is the ratio of the Total Labor Force (in %) of Small states in 1996 to that in 1997?
Give a very brief answer. 1. What is the ratio of the Total Labor Force (in %) of Fragile and conflict affected situations in 1996 to that in 1998?
Give a very brief answer. 1. What is the ratio of the Total Labor Force (in %) in Small states in 1996 to that in 1998?
Provide a succinct answer. 1. What is the ratio of the Total Labor Force (in %) in Bhutan in 1996 to that in 1998?
Keep it short and to the point. 0.99. What is the ratio of the Total Labor Force (in %) of Israel in 1996 to that in 1998?
Your answer should be very brief. 1. What is the ratio of the Total Labor Force (in %) in Fragile and conflict affected situations in 1996 to that in 1999?
Your response must be concise. 1. What is the ratio of the Total Labor Force (in %) of Bhutan in 1996 to that in 1999?
Your response must be concise. 0.97. What is the ratio of the Total Labor Force (in %) in Israel in 1996 to that in 1999?
Offer a terse response. 0.99. What is the ratio of the Total Labor Force (in %) in Fragile and conflict affected situations in 1997 to that in 1998?
Offer a very short reply. 1. What is the ratio of the Total Labor Force (in %) of Small states in 1997 to that in 1998?
Make the answer very short. 1. What is the ratio of the Total Labor Force (in %) of Israel in 1997 to that in 1998?
Provide a short and direct response. 1. What is the ratio of the Total Labor Force (in %) of Small states in 1997 to that in 1999?
Your answer should be compact. 1. What is the ratio of the Total Labor Force (in %) in Bhutan in 1997 to that in 1999?
Your response must be concise. 0.98. What is the ratio of the Total Labor Force (in %) in Israel in 1997 to that in 1999?
Ensure brevity in your answer.  0.99. What is the ratio of the Total Labor Force (in %) of Small states in 1998 to that in 1999?
Offer a terse response. 1. What is the ratio of the Total Labor Force (in %) of Israel in 1998 to that in 1999?
Provide a short and direct response. 0.99. What is the difference between the highest and the second highest Total Labor Force (in %) of Fragile and conflict affected situations?
Give a very brief answer. 0. What is the difference between the highest and the second highest Total Labor Force (in %) of Small states?
Your response must be concise. 0.1. What is the difference between the highest and the second highest Total Labor Force (in %) of Bhutan?
Your response must be concise. 0.8. What is the difference between the highest and the second highest Total Labor Force (in %) in Israel?
Your answer should be very brief. 0.3. What is the difference between the highest and the lowest Total Labor Force (in %) in Fragile and conflict affected situations?
Make the answer very short. 0.22. What is the difference between the highest and the lowest Total Labor Force (in %) of Small states?
Your answer should be very brief. 0.42. What is the difference between the highest and the lowest Total Labor Force (in %) in Israel?
Your answer should be compact. 1.6. 